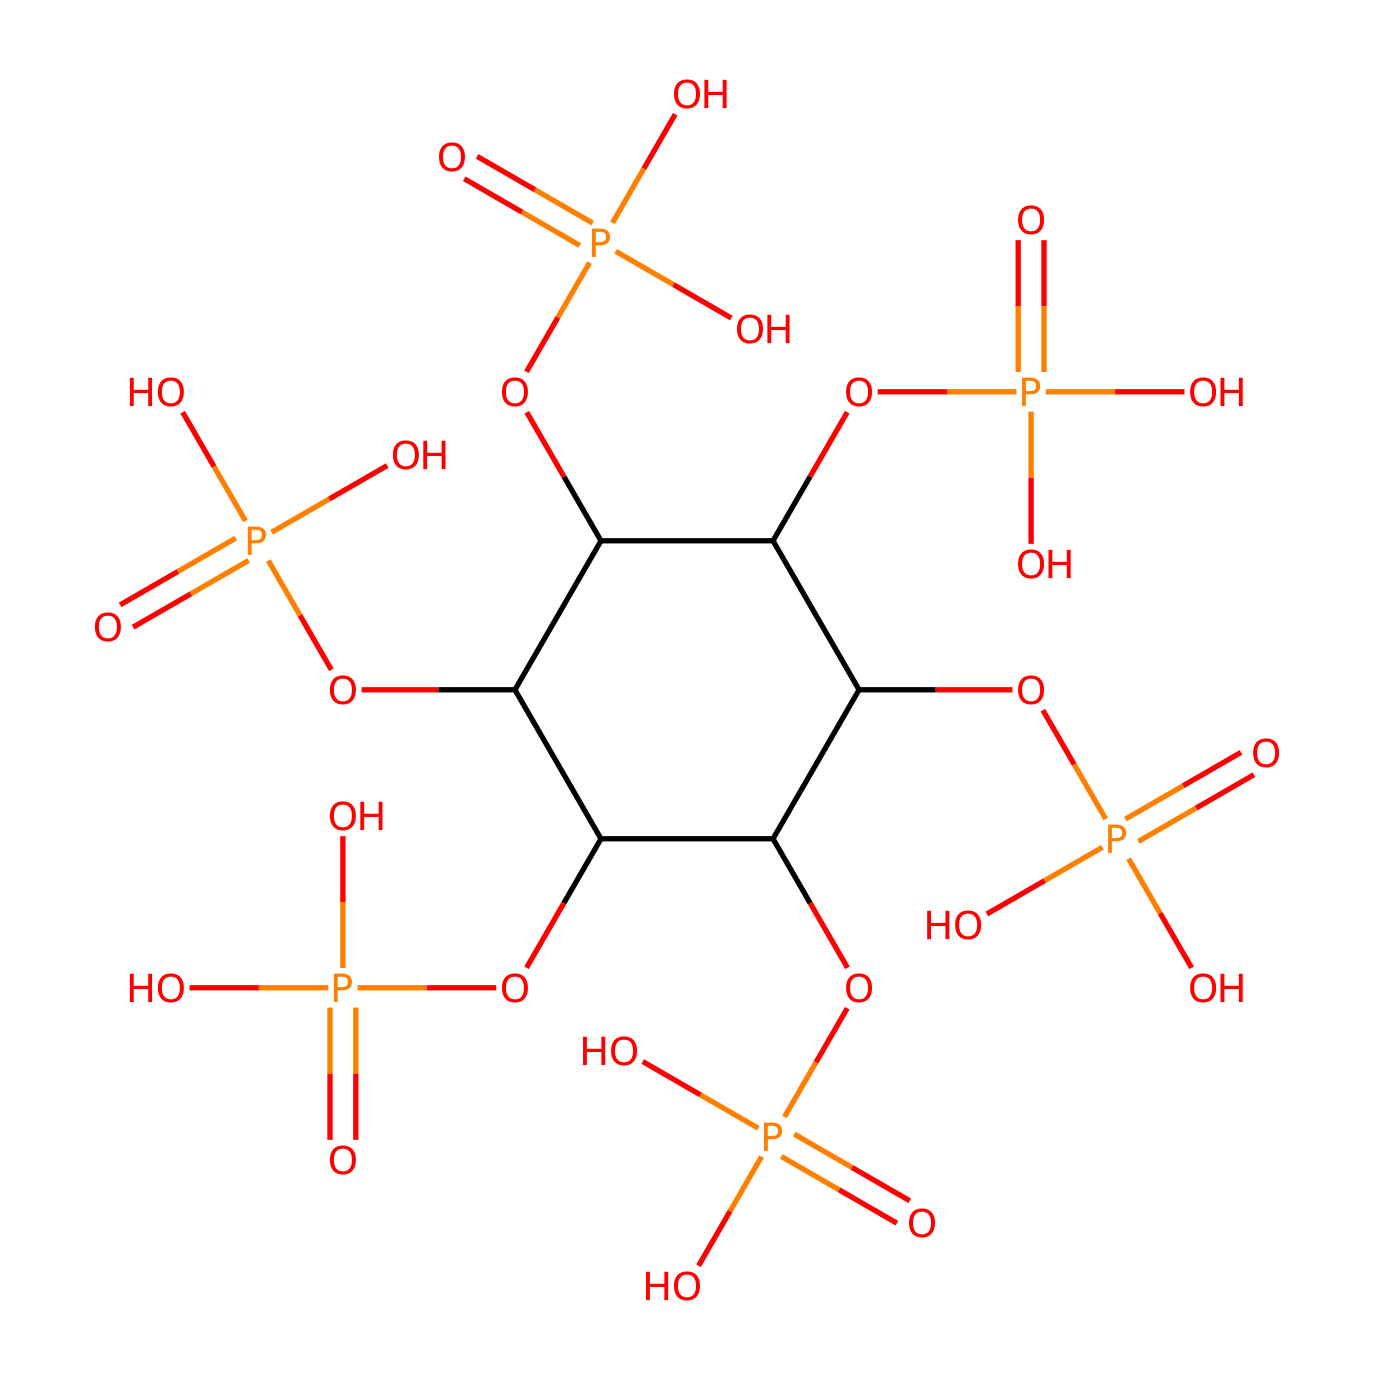What is the molecular formula of phytic acid? To determine the molecular formula, we count the carbon (C), hydrogen (H), oxygen (O), and phosphorus (P) atoms in the SMILES representation. There are 6 carbon atoms, 18 hydrogen atoms, 6 oxygen atoms, and 6 phosphorus atoms, leading to the molecular formula C6H18O24P6.
Answer: C6H18O24P6 How many phosphorus atoms are present in phytic acid? By inspecting the SMILES representation, we identify the phosphorus (P) atoms, specifically noting there are 6 instances of phosphorus in the structure.
Answer: 6 What functional groups are present in phytic acid? In the SMILES representation, we see multiple instances of phosphate (OP(=O)(O)O), which indicates the presence of phosphate groups, classifying phytic acid as containing multiple phosphate functional groups.
Answer: phosphate groups Which part of the structure indicates it is a phosphorus compound? The presence of phosphorus atoms, denoted by the letter 'P' in the SMILES, specifically where phosphorus forms bonds with oxygen, indicates that this compound is classified as a phosphorus compound.
Answer: phosphorus atoms What is the total number of hydrogen atoms connected to the carbon backbone? By analyzing the structure derived from the SMILES, we can count each hydrogen atom attached to the carbon structure; there are 18 hydrogen atoms in total connected to the carbon backbone.
Answer: 18 How does the structure of phytic acid relate to its function as an anti-nutrient? The multiple phosphate groups in the structure can bind to minerals such as iron and zinc, making them less available for absorption in the body, highlighting its role as an anti-nutrient.
Answer: binds minerals What is the role of phytic acid in plants? Phytic acid serves as a storage form of phosphorus for plants, which is released when the seeds germinate. This indicates it plays a vital role in plant nutrition and energy.
Answer: storage of phosphorus 